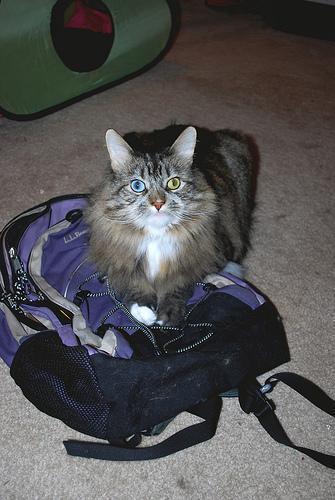How many eye colors has the cat?
Give a very brief answer. 2. How many cats are there?
Give a very brief answer. 1. 